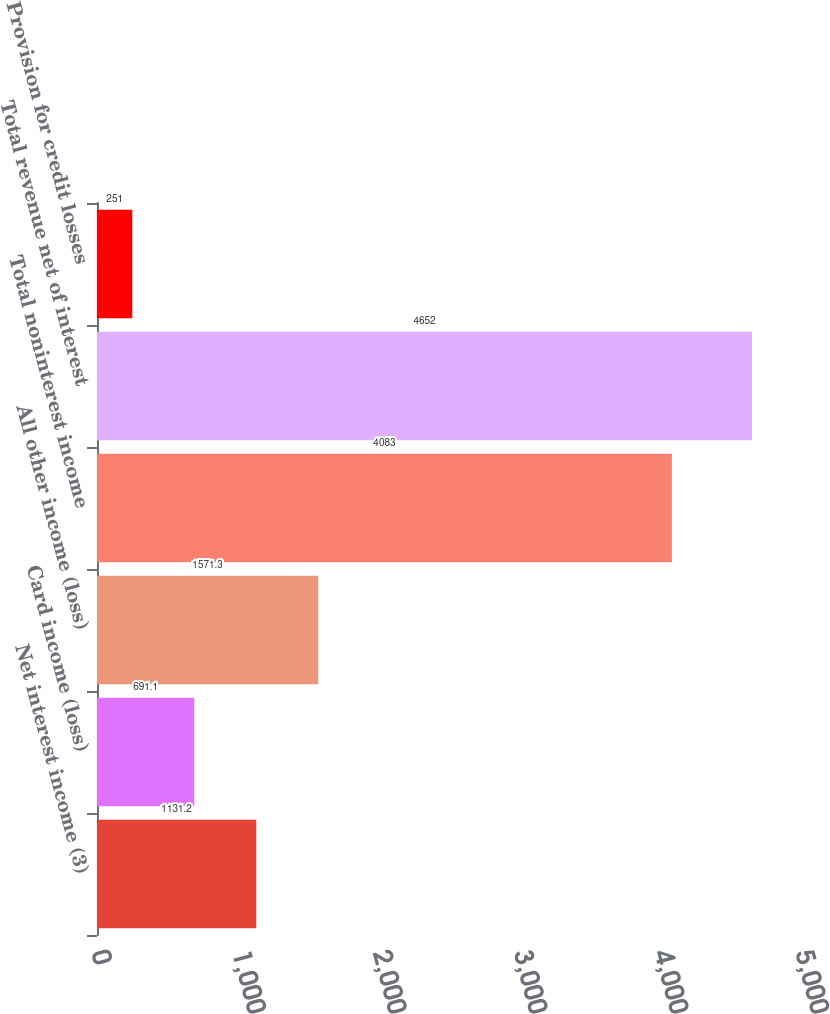<chart> <loc_0><loc_0><loc_500><loc_500><bar_chart><fcel>Net interest income (3)<fcel>Card income (loss)<fcel>All other income (loss)<fcel>Total noninterest income<fcel>Total revenue net of interest<fcel>Provision for credit losses<nl><fcel>1131.2<fcel>691.1<fcel>1571.3<fcel>4083<fcel>4652<fcel>251<nl></chart> 